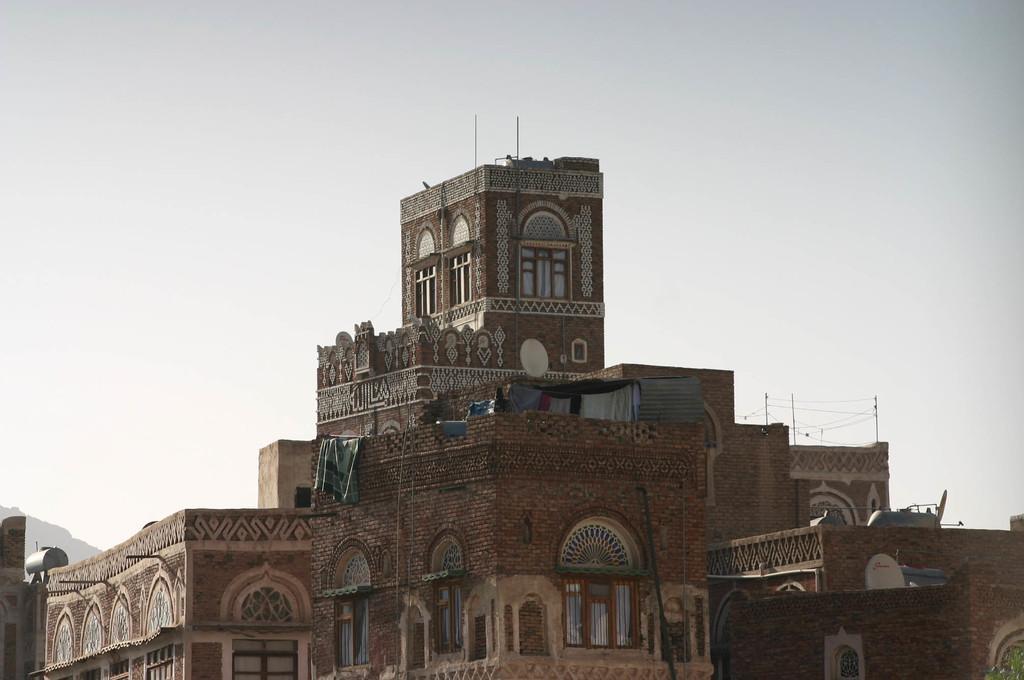How would you summarize this image in a sentence or two? In the foreground of this image, there are buildings. At the top, there is the sky. 